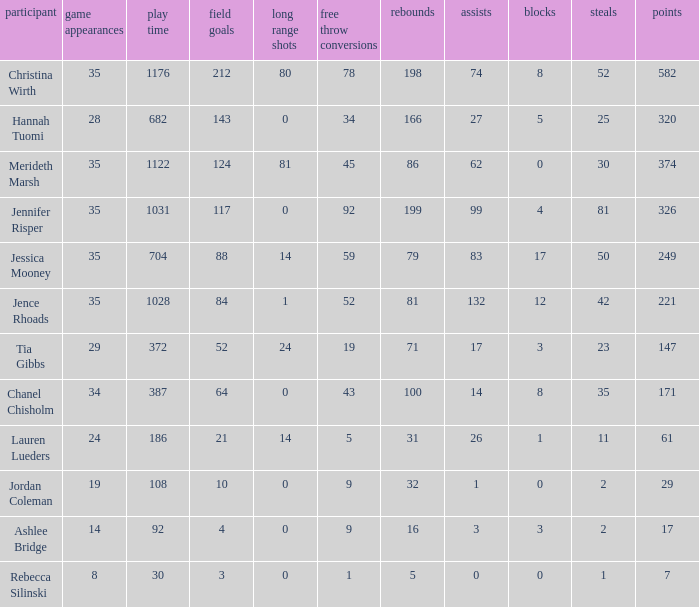How much time, in minutes, did Chanel Chisholm play? 1.0. 